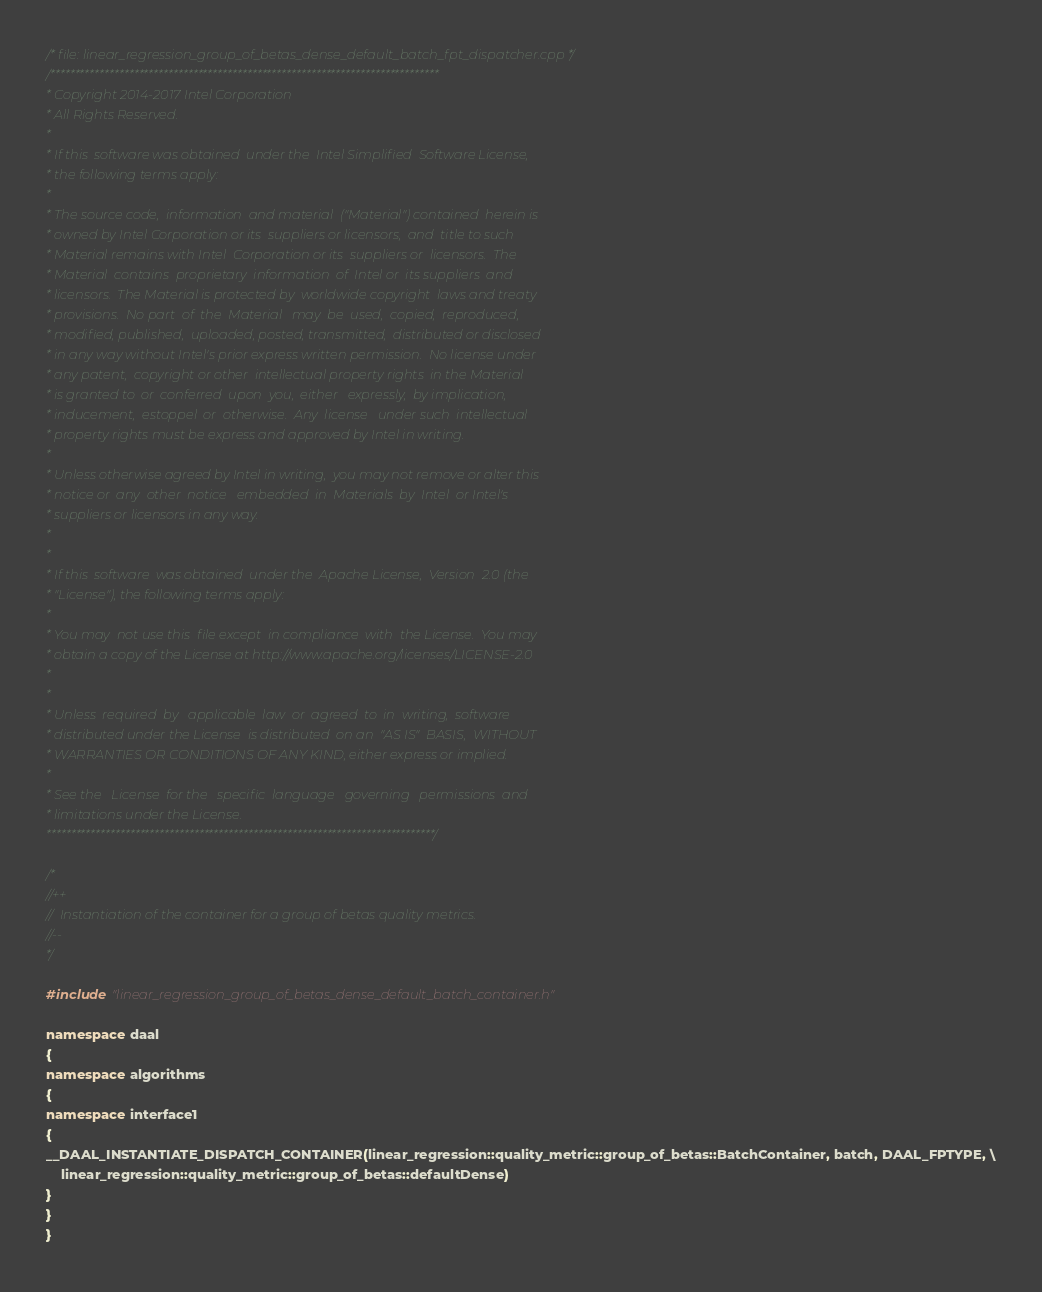Convert code to text. <code><loc_0><loc_0><loc_500><loc_500><_C++_>/* file: linear_regression_group_of_betas_dense_default_batch_fpt_dispatcher.cpp */
/*******************************************************************************
* Copyright 2014-2017 Intel Corporation
* All Rights Reserved.
*
* If this  software was obtained  under the  Intel Simplified  Software License,
* the following terms apply:
*
* The source code,  information  and material  ("Material") contained  herein is
* owned by Intel Corporation or its  suppliers or licensors,  and  title to such
* Material remains with Intel  Corporation or its  suppliers or  licensors.  The
* Material  contains  proprietary  information  of  Intel or  its suppliers  and
* licensors.  The Material is protected by  worldwide copyright  laws and treaty
* provisions.  No part  of  the  Material   may  be  used,  copied,  reproduced,
* modified, published,  uploaded, posted, transmitted,  distributed or disclosed
* in any way without Intel's prior express written permission.  No license under
* any patent,  copyright or other  intellectual property rights  in the Material
* is granted to  or  conferred  upon  you,  either   expressly,  by implication,
* inducement,  estoppel  or  otherwise.  Any  license   under such  intellectual
* property rights must be express and approved by Intel in writing.
*
* Unless otherwise agreed by Intel in writing,  you may not remove or alter this
* notice or  any  other  notice   embedded  in  Materials  by  Intel  or Intel's
* suppliers or licensors in any way.
*
*
* If this  software  was obtained  under the  Apache License,  Version  2.0 (the
* "License"), the following terms apply:
*
* You may  not use this  file except  in compliance  with  the License.  You may
* obtain a copy of the License at http://www.apache.org/licenses/LICENSE-2.0
*
*
* Unless  required  by   applicable  law  or  agreed  to  in  writing,  software
* distributed under the License  is distributed  on an  "AS IS"  BASIS,  WITHOUT
* WARRANTIES OR CONDITIONS OF ANY KIND, either express or implied.
*
* See the   License  for the   specific  language   governing   permissions  and
* limitations under the License.
*******************************************************************************/

/*
//++
//  Instantiation of the container for a group of betas quality metrics.
//--
*/

#include "linear_regression_group_of_betas_dense_default_batch_container.h"

namespace daal
{
namespace algorithms
{
namespace interface1
{
__DAAL_INSTANTIATE_DISPATCH_CONTAINER(linear_regression::quality_metric::group_of_betas::BatchContainer, batch, DAAL_FPTYPE, \
    linear_regression::quality_metric::group_of_betas::defaultDense)
}
}
}
</code> 